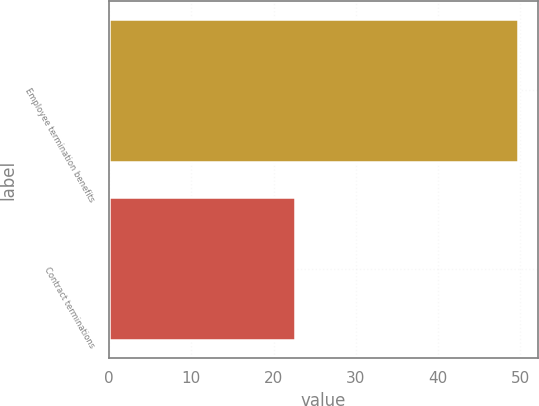Convert chart. <chart><loc_0><loc_0><loc_500><loc_500><bar_chart><fcel>Employee termination benefits<fcel>Contract terminations<nl><fcel>49.7<fcel>22.6<nl></chart> 